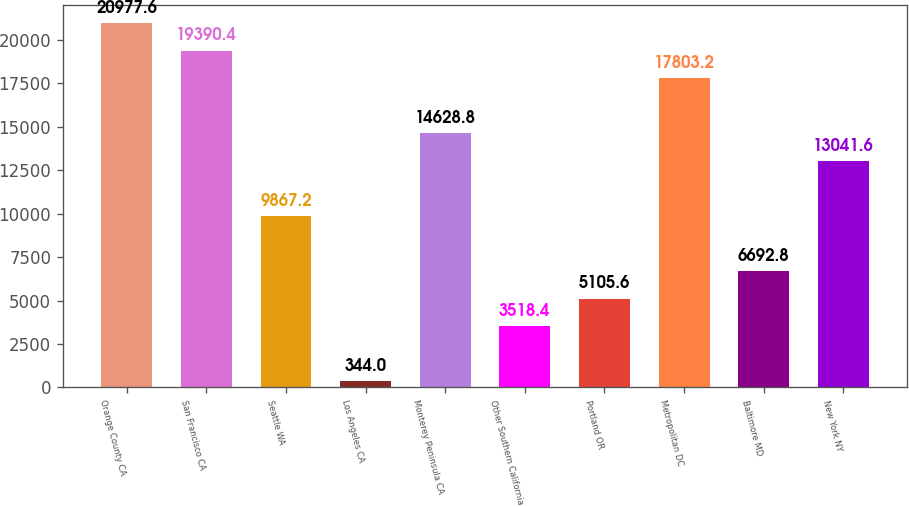Convert chart to OTSL. <chart><loc_0><loc_0><loc_500><loc_500><bar_chart><fcel>Orange County CA<fcel>San Francisco CA<fcel>Seattle WA<fcel>Los Angeles CA<fcel>Monterey Peninsula CA<fcel>Other Southern California<fcel>Portland OR<fcel>Metropolitan DC<fcel>Baltimore MD<fcel>New York NY<nl><fcel>20977.6<fcel>19390.4<fcel>9867.2<fcel>344<fcel>14628.8<fcel>3518.4<fcel>5105.6<fcel>17803.2<fcel>6692.8<fcel>13041.6<nl></chart> 